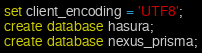<code> <loc_0><loc_0><loc_500><loc_500><_SQL_>set client_encoding = 'UTF8';
create database hasura;
create database nexus_prisma;
</code> 